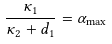<formula> <loc_0><loc_0><loc_500><loc_500>\frac { \kappa _ { 1 } } { \kappa _ { 2 } + d _ { 1 } } = \alpha _ { \max }</formula> 